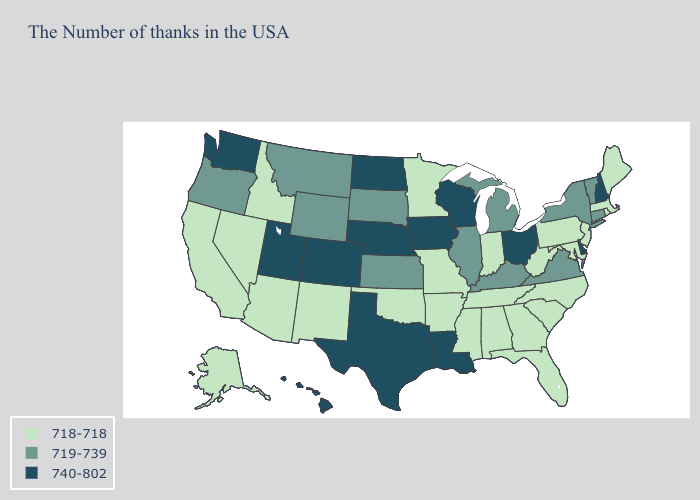Does Washington have the same value as Utah?
Keep it brief. Yes. Does Washington have the lowest value in the USA?
Write a very short answer. No. What is the value of Kansas?
Answer briefly. 719-739. Which states have the lowest value in the West?
Short answer required. New Mexico, Arizona, Idaho, Nevada, California, Alaska. What is the value of Oregon?
Quick response, please. 719-739. What is the value of Ohio?
Be succinct. 740-802. What is the value of New York?
Write a very short answer. 719-739. Among the states that border Mississippi , does Alabama have the lowest value?
Give a very brief answer. Yes. Which states have the lowest value in the South?
Write a very short answer. Maryland, North Carolina, South Carolina, West Virginia, Florida, Georgia, Alabama, Tennessee, Mississippi, Arkansas, Oklahoma. What is the value of Mississippi?
Concise answer only. 718-718. Name the states that have a value in the range 740-802?
Write a very short answer. New Hampshire, Delaware, Ohio, Wisconsin, Louisiana, Iowa, Nebraska, Texas, North Dakota, Colorado, Utah, Washington, Hawaii. What is the value of New York?
Write a very short answer. 719-739. What is the value of Kentucky?
Concise answer only. 719-739. Does Ohio have the lowest value in the USA?
Keep it brief. No. 